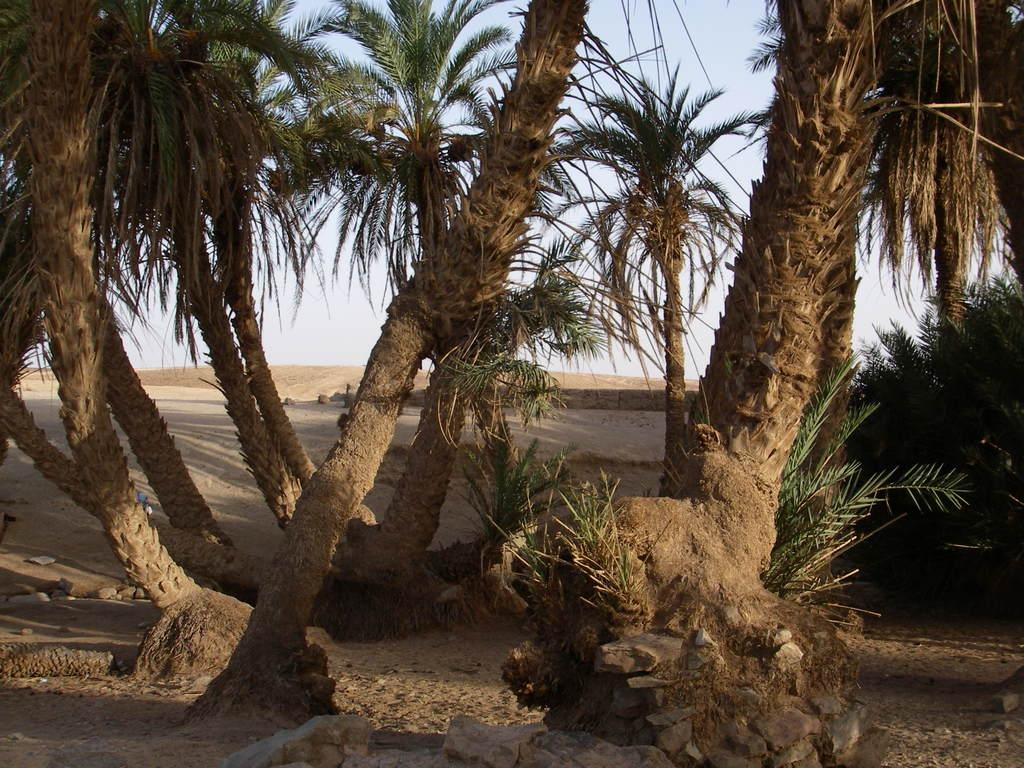What type of vegetation can be seen in the image? There are trees and plants on the ground in the image. What can be seen in the background of the image? The sky is visible in the background of the image. How would you describe the sky in the image? The sky appears to be clear in the image. What type of whip is being used to control the plants in the image? There is no whip present in the image, and the plants are not being controlled by any external force. 